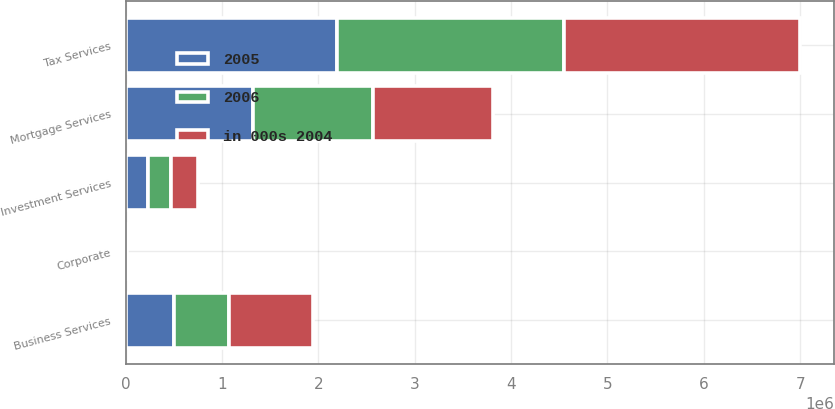Convert chart. <chart><loc_0><loc_0><loc_500><loc_500><stacked_bar_chart><ecel><fcel>Tax Services<fcel>Mortgage Services<fcel>Business Services<fcel>Investment Services<fcel>Corporate<nl><fcel>in 000s 2004<fcel>2.45181e+06<fcel>1.24714e+06<fcel>877259<fcel>287955<fcel>8643<nl><fcel>2006<fcel>2.35829e+06<fcel>1.24602e+06<fcel>573316<fcel>239244<fcel>3148<nl><fcel>2005<fcel>2.19118e+06<fcel>1.32371e+06<fcel>499210<fcel>229470<fcel>4314<nl></chart> 